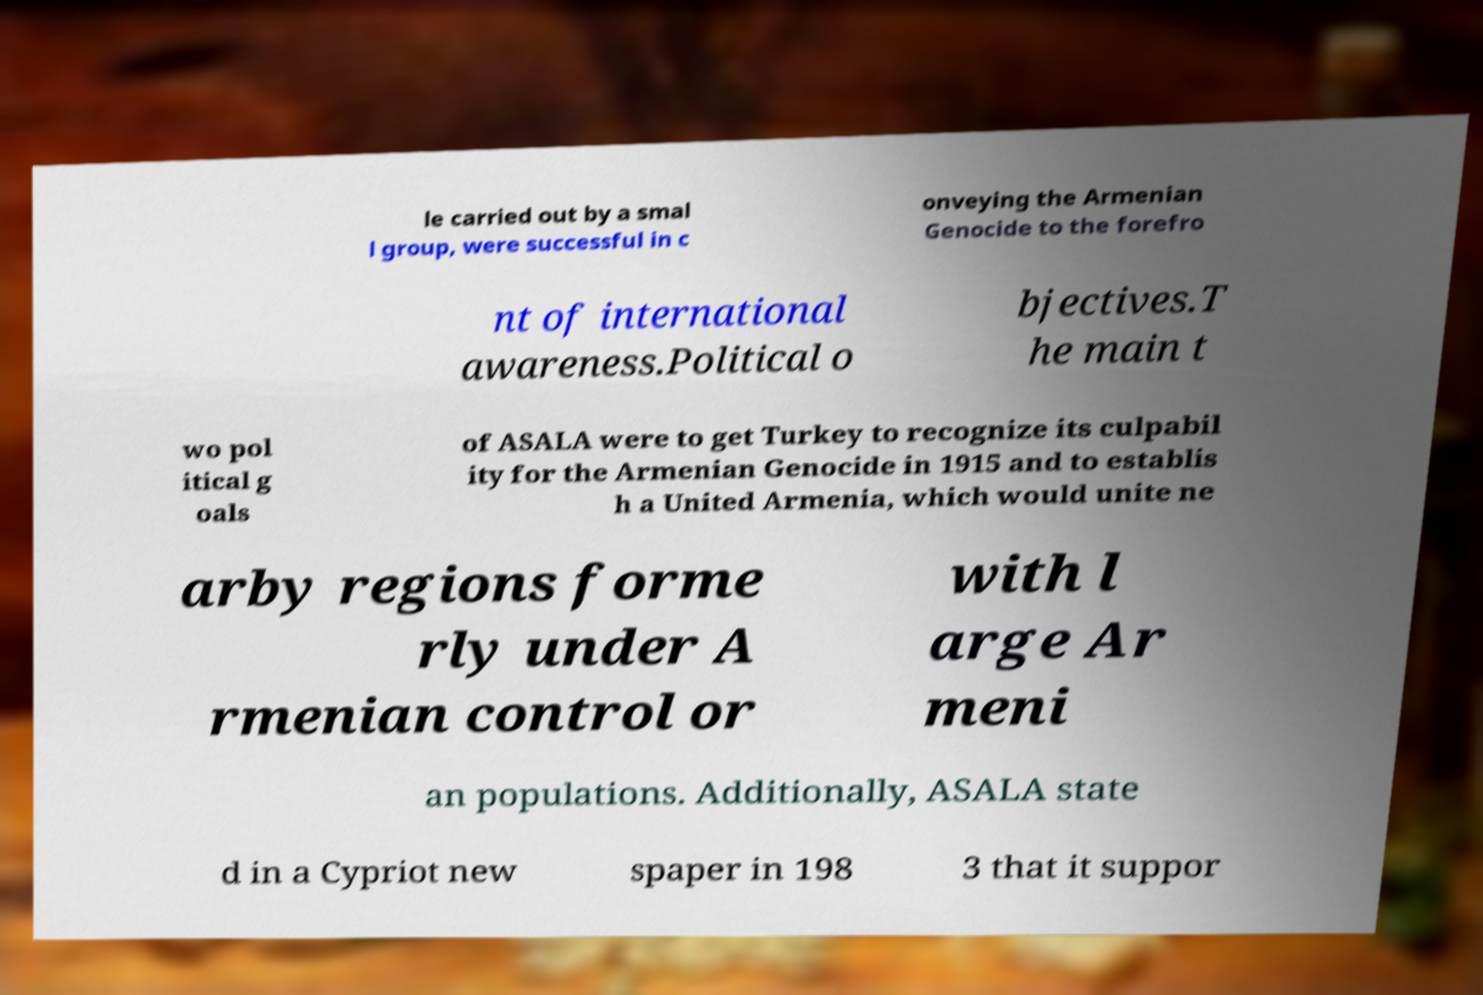Can you read and provide the text displayed in the image?This photo seems to have some interesting text. Can you extract and type it out for me? le carried out by a smal l group, were successful in c onveying the Armenian Genocide to the forefro nt of international awareness.Political o bjectives.T he main t wo pol itical g oals of ASALA were to get Turkey to recognize its culpabil ity for the Armenian Genocide in 1915 and to establis h a United Armenia, which would unite ne arby regions forme rly under A rmenian control or with l arge Ar meni an populations. Additionally, ASALA state d in a Cypriot new spaper in 198 3 that it suppor 